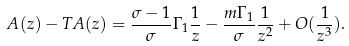<formula> <loc_0><loc_0><loc_500><loc_500>A ( z ) - T A ( z ) = \frac { \sigma - 1 } { \sigma } \Gamma _ { 1 } \frac { 1 } { z } - \frac { m \Gamma _ { 1 } } { \sigma } \frac { 1 } { z ^ { 2 } } + O ( \frac { 1 } { z ^ { 3 } } ) .</formula> 